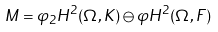<formula> <loc_0><loc_0><loc_500><loc_500>M = \varphi _ { 2 } H ^ { 2 } ( \Omega , K ) \ominus \varphi { H ^ { 2 } ( \Omega , F ) }</formula> 